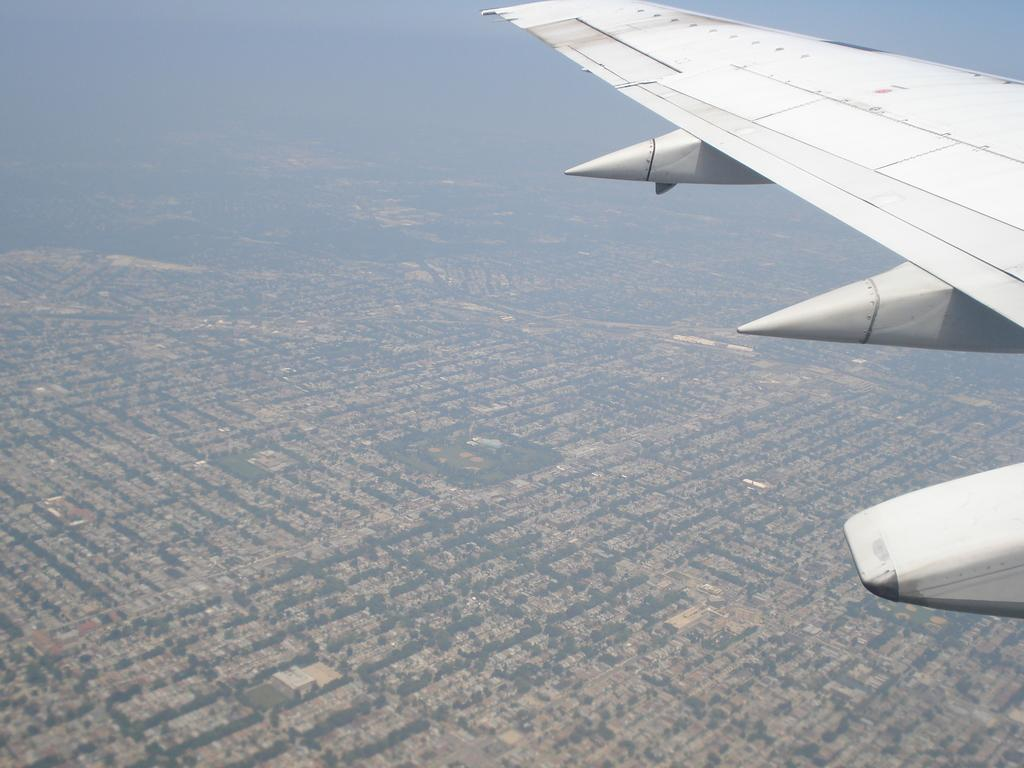What type of transportation is featured in the image? There is a flight elevator in the image. What can be seen in the background of the image? There are trees and a house visible in the background of the image. What type of wrench is being used to fix the flight elevator in the image? There is no wrench present in the image, and the flight elevator does not appear to be in need of repair. 